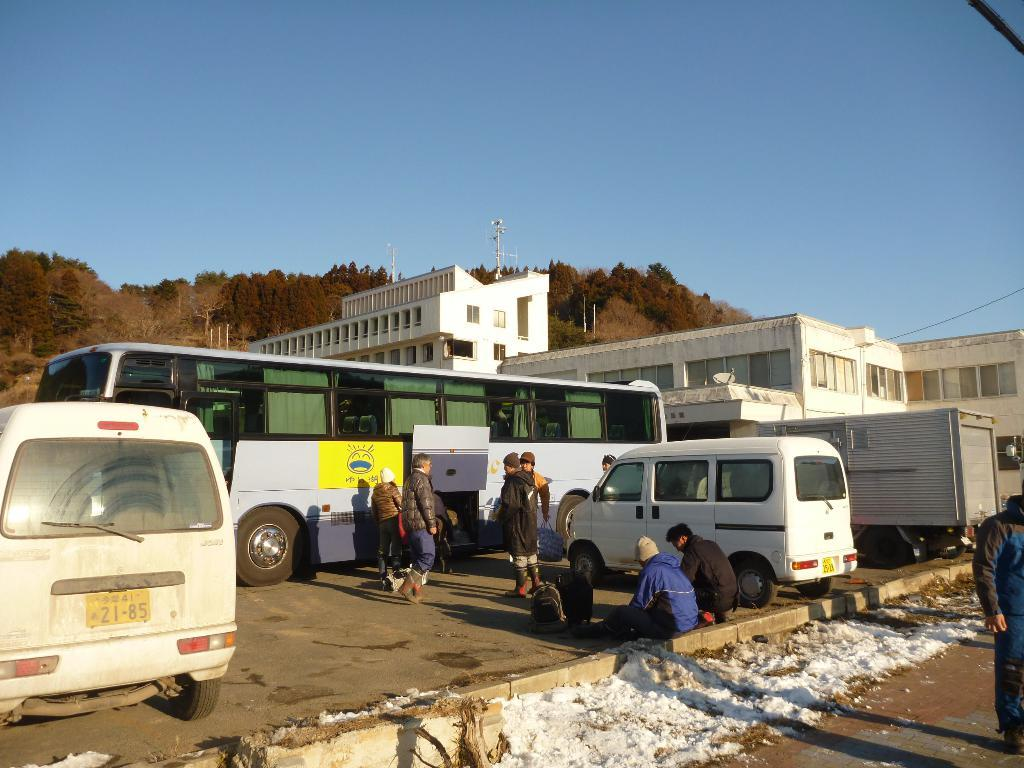What is covering the ground at the bottom of the image? There is snow at the bottom of the image. Who or what can be seen in the image? There are people and vehicles in the image. What can be seen in the distance in the image? There are houses and trees in the background of the image. What is visible at the top of the image? The sky is visible at the top of the image. What type of power is being generated by the snow in the image? There is no power generation mentioned or depicted in the image; it simply shows snow on the ground. Can you see any roses growing in the snow in the image? There are no roses present in the image; it only shows snow, people, vehicles, houses, trees, and the sky. 